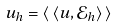<formula> <loc_0><loc_0><loc_500><loc_500>u _ { h } = \langle \, \langle u , \mathcal { E } _ { h } \rangle \, \rangle</formula> 